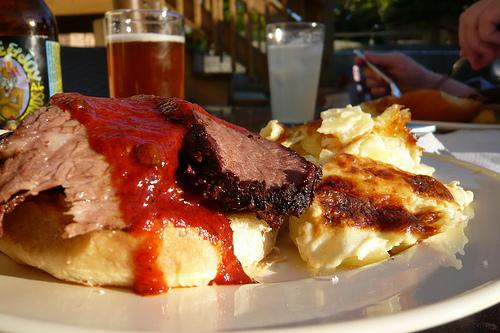Identify and briefly describe the eating action happening in the image. A man is eating food using a fork and knife while holding the utensils. Describe any dish in the image that contains red sauce. There is a steak sandwich with red sauce on it, and the sauce is dripping off the side of the plate. Mention the types of beverages present in the image. There is a glass of beer, a glass of lemonade, and a bottle of beer in the image. Describe any seafood-related dish presented in the image. There is a cooked fish on the plate among other food items. If you were planning a marketing campaign for this restaurant, highlight some dishes and drinks in the image. Try our delicious steak sandwich with our signature red sauce or indulge in our perfectly cooked fish, accompanied by a refreshing glass of lemonade or an ice-cold beer. What is the color of the plate and what kind of food is placed on it? The plate is white and has a variety of food including a steak sandwich, macaroni, beef on a biscuit, and scalloped potatoes. Explain the general setting of the photograph. The photograph is taken at a restaurant with various food and drinks on the table and a brown staircase in the background. 